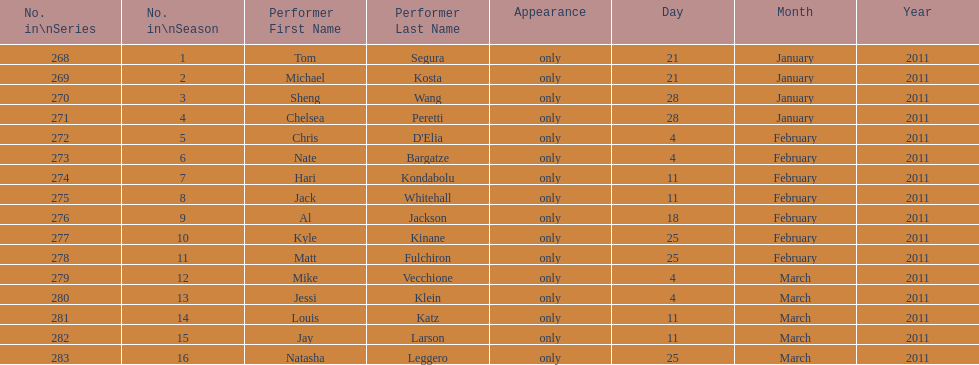What is the name of the last performer on this chart? Natasha Leggero. 